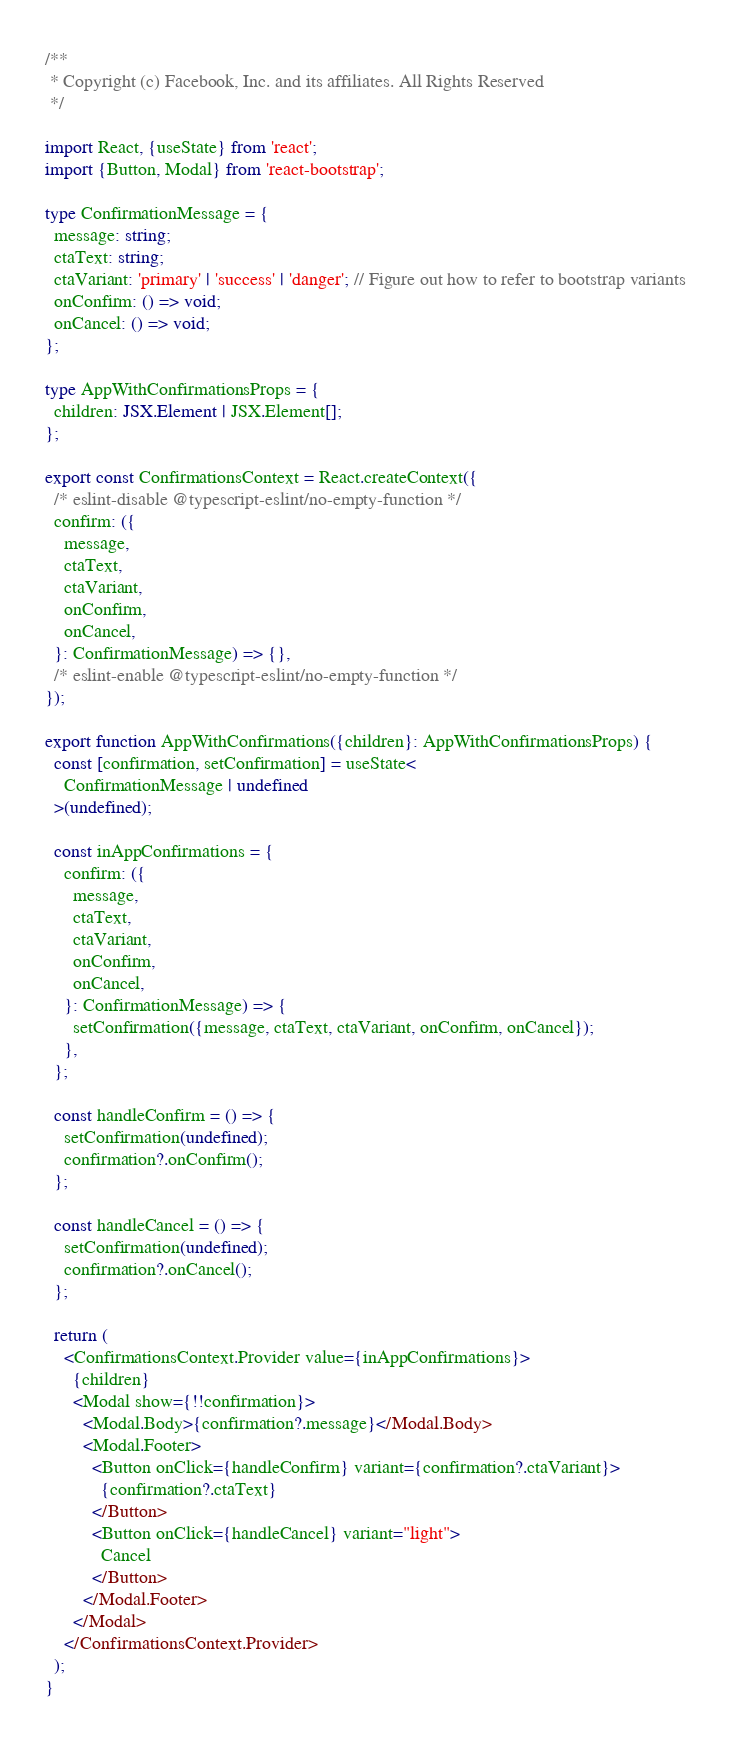<code> <loc_0><loc_0><loc_500><loc_500><_TypeScript_>/**
 * Copyright (c) Facebook, Inc. and its affiliates. All Rights Reserved
 */

import React, {useState} from 'react';
import {Button, Modal} from 'react-bootstrap';

type ConfirmationMessage = {
  message: string;
  ctaText: string;
  ctaVariant: 'primary' | 'success' | 'danger'; // Figure out how to refer to bootstrap variants
  onConfirm: () => void;
  onCancel: () => void;
};

type AppWithConfirmationsProps = {
  children: JSX.Element | JSX.Element[];
};

export const ConfirmationsContext = React.createContext({
  /* eslint-disable @typescript-eslint/no-empty-function */
  confirm: ({
    message,
    ctaText,
    ctaVariant,
    onConfirm,
    onCancel,
  }: ConfirmationMessage) => {},
  /* eslint-enable @typescript-eslint/no-empty-function */
});

export function AppWithConfirmations({children}: AppWithConfirmationsProps) {
  const [confirmation, setConfirmation] = useState<
    ConfirmationMessage | undefined
  >(undefined);

  const inAppConfirmations = {
    confirm: ({
      message,
      ctaText,
      ctaVariant,
      onConfirm,
      onCancel,
    }: ConfirmationMessage) => {
      setConfirmation({message, ctaText, ctaVariant, onConfirm, onCancel});
    },
  };

  const handleConfirm = () => {
    setConfirmation(undefined);
    confirmation?.onConfirm();
  };

  const handleCancel = () => {
    setConfirmation(undefined);
    confirmation?.onCancel();
  };

  return (
    <ConfirmationsContext.Provider value={inAppConfirmations}>
      {children}
      <Modal show={!!confirmation}>
        <Modal.Body>{confirmation?.message}</Modal.Body>
        <Modal.Footer>
          <Button onClick={handleConfirm} variant={confirmation?.ctaVariant}>
            {confirmation?.ctaText}
          </Button>
          <Button onClick={handleCancel} variant="light">
            Cancel
          </Button>
        </Modal.Footer>
      </Modal>
    </ConfirmationsContext.Provider>
  );
}
</code> 